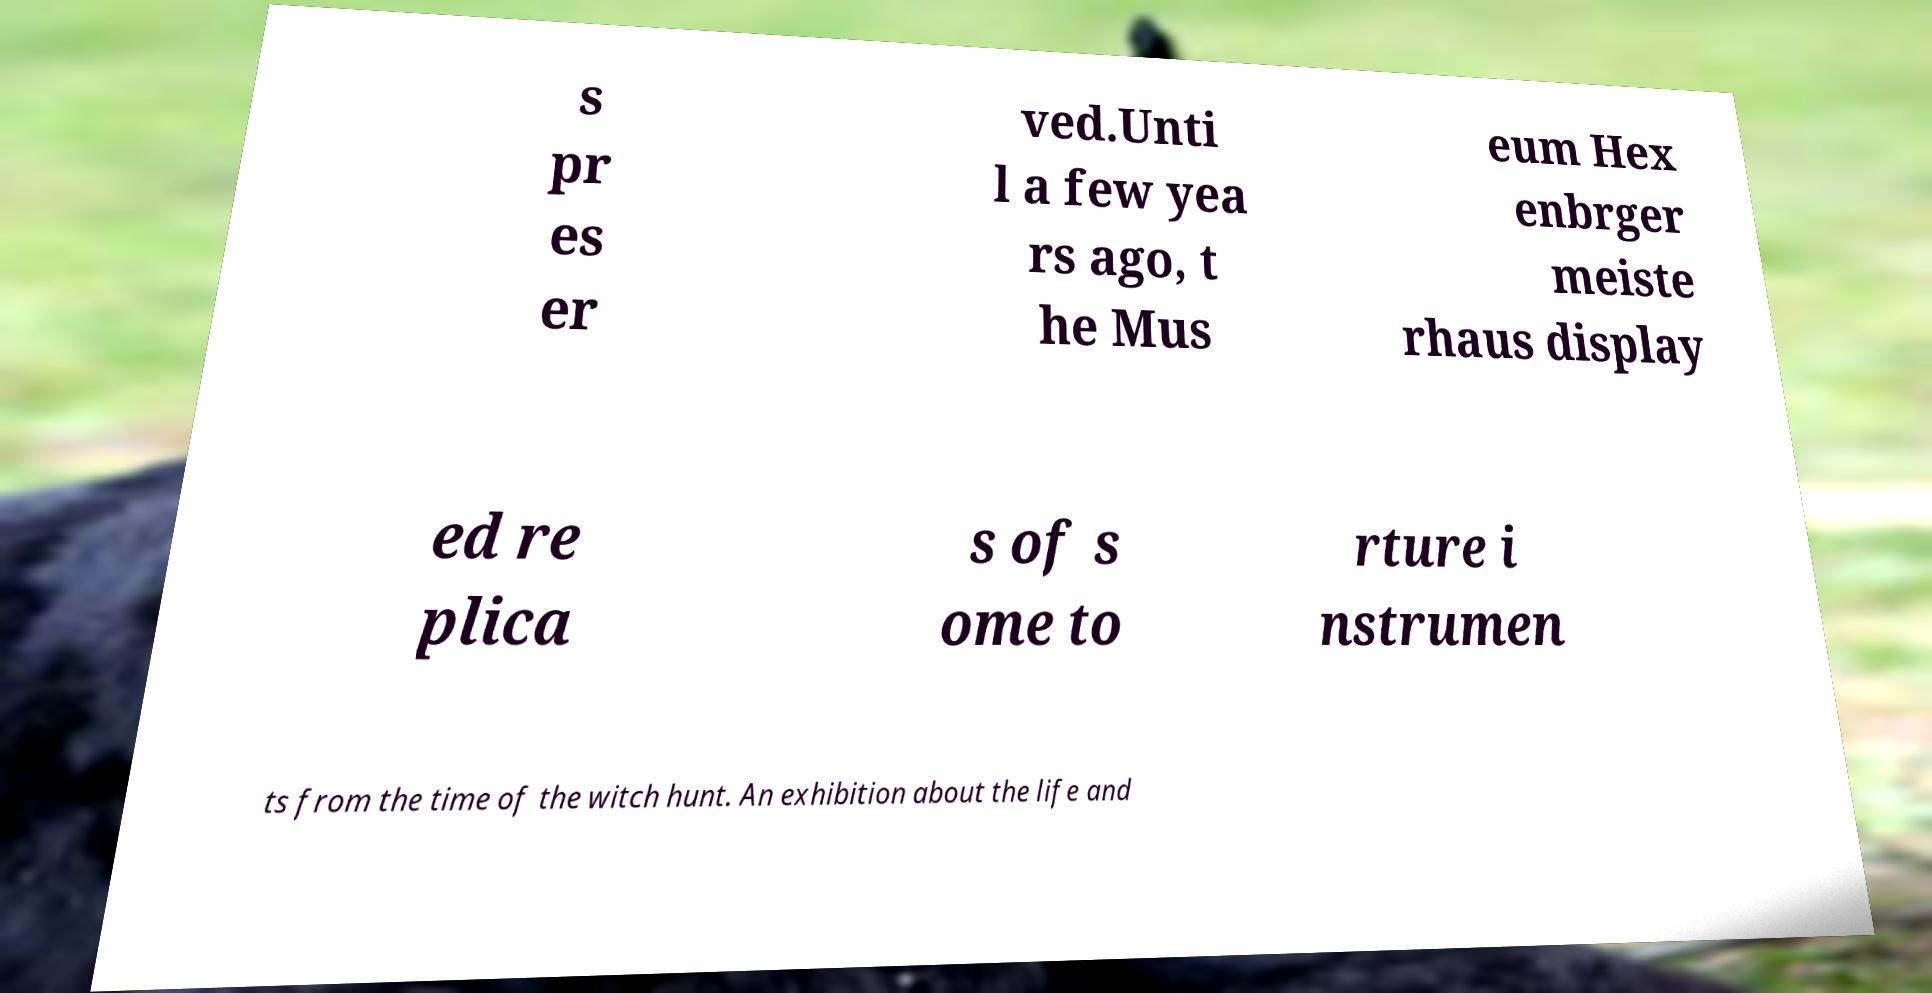Please identify and transcribe the text found in this image. s pr es er ved.Unti l a few yea rs ago, t he Mus eum Hex enbrger meiste rhaus display ed re plica s of s ome to rture i nstrumen ts from the time of the witch hunt. An exhibition about the life and 